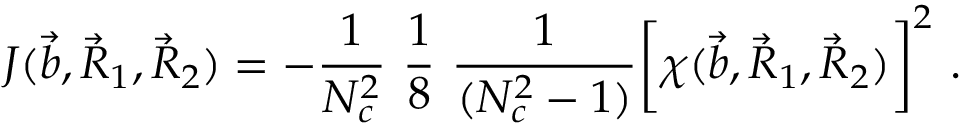Convert formula to latex. <formula><loc_0><loc_0><loc_500><loc_500>J ( \vec { b } , \vec { R } _ { 1 } , \vec { R } _ { 2 } ) = - { \frac { 1 } { N _ { c } ^ { 2 } } } \ { \frac { 1 } { 8 } } \ { \frac { 1 } { ( N _ { c } ^ { 2 } - 1 ) } } \left [ \chi ( \vec { b } , \vec { R } _ { 1 } , \vec { R } _ { 2 } ) \right ] ^ { 2 } .</formula> 